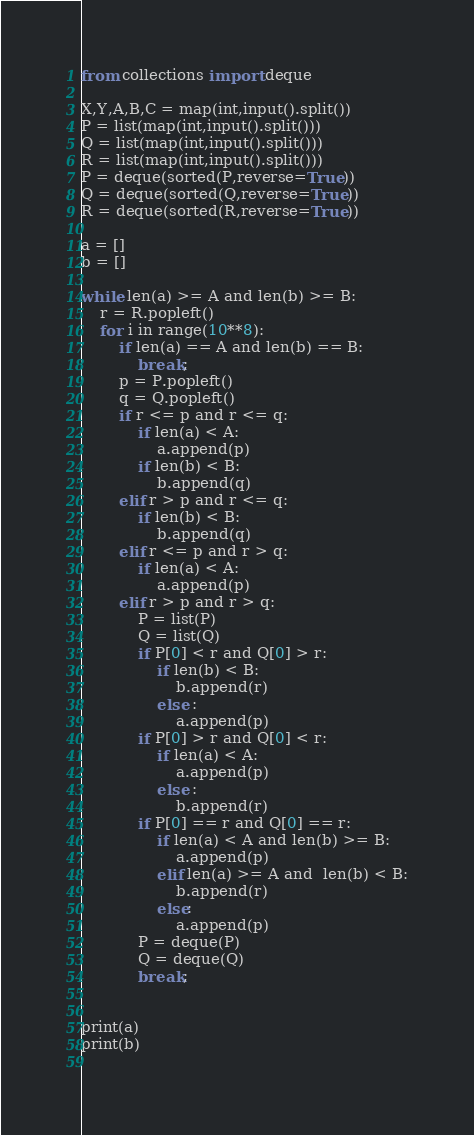<code> <loc_0><loc_0><loc_500><loc_500><_Python_>from collections import deque

X,Y,A,B,C = map(int,input().split())
P = list(map(int,input().split()))
Q = list(map(int,input().split()))
R = list(map(int,input().split()))
P = deque(sorted(P,reverse=True))
Q = deque(sorted(Q,reverse=True))
R = deque(sorted(R,reverse=True))

a = []
b = []

while len(a) >= A and len(b) >= B:
    r = R.popleft()
    for i in range(10**8):
        if len(a) == A and len(b) == B:
            break;
        p = P.popleft()
        q = Q.popleft()
        if r <= p and r <= q:
            if len(a) < A:
                a.append(p)
            if len(b) < B:
                b.append(q)
        elif r > p and r <= q:
            if len(b) < B:
                b.append(q)
        elif r <= p and r > q:
            if len(a) < A:
                a.append(p)
        elif r > p and r > q:
            P = list(P)
            Q = list(Q)
            if P[0] < r and Q[0] > r:
                if len(b) < B:
                    b.append(r)
                else :
                    a.append(p)    
            if P[0] > r and Q[0] < r:
                if len(a) < A:
                    a.append(p)
                else :
                    b.append(r)
            if P[0] == r and Q[0] == r:
                if len(a) < A and len(b) >= B:
                    a.append(p)
                elif len(a) >= A and  len(b) < B:
                    b.append(r)
                else:
                    a.append(p)
            P = deque(P)
            Q = deque(Q)
            break;


print(a)
print(b)
            




</code> 